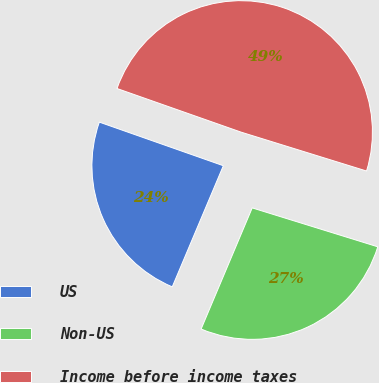Convert chart. <chart><loc_0><loc_0><loc_500><loc_500><pie_chart><fcel>US<fcel>Non-US<fcel>Income before income taxes<nl><fcel>24.03%<fcel>26.57%<fcel>49.4%<nl></chart> 